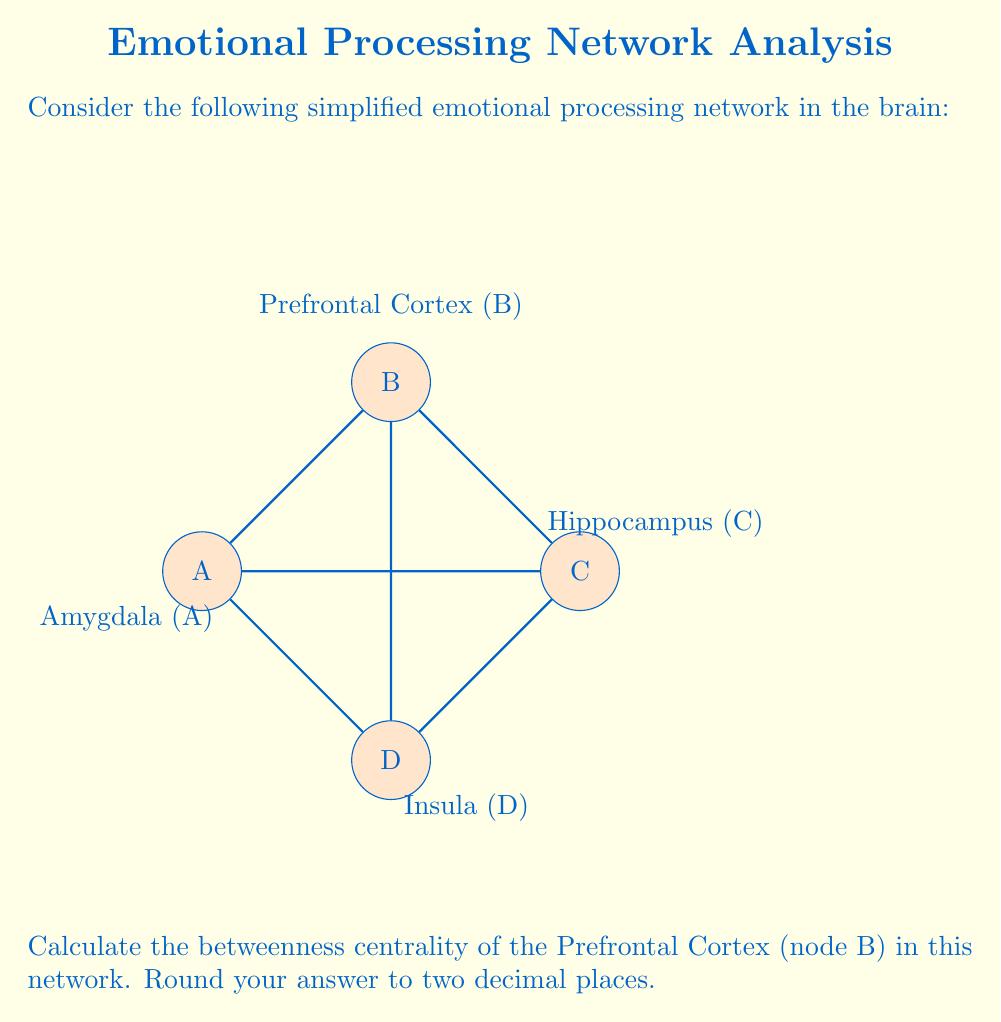Help me with this question. To calculate the betweenness centrality of node B (Prefrontal Cortex), we need to follow these steps:

1) First, recall that betweenness centrality is calculated as:

   $$C_B(v) = \sum_{s \neq v \neq t} \frac{\sigma_{st}(v)}{\sigma_{st}}$$

   where $\sigma_{st}$ is the total number of shortest paths from node s to node t, and $\sigma_{st}(v)$ is the number of those paths that pass through v.

2) In this network, we need to consider all pairs of nodes excluding B:
   (A,C), (A,D), (C,D)

3) For each pair, calculate the shortest paths:
   
   A to C: A-C (direct) and A-B-C
   A to D: A-D (direct)
   C to D: C-D (direct)

4) Now, count how many of these shortest paths pass through B:
   
   A to C: 1 out of 2 paths passes through B
   A to D: 0 out of 1 path passes through B
   C to D: 0 out of 1 path passes through B

5) Apply the formula:

   $$C_B(B) = \frac{1}{2} + 0 + 0 = 0.5$$

6) As there are no decimal places, no rounding is necessary.
Answer: 0.50 